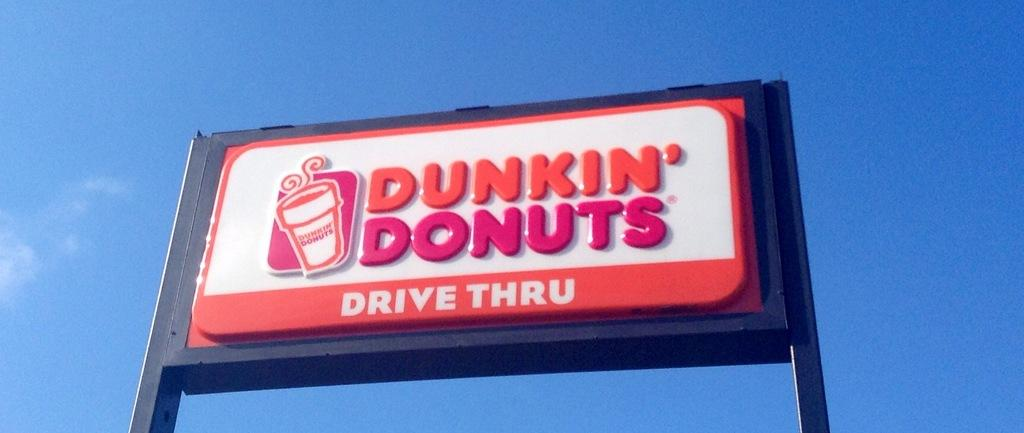<image>
Present a compact description of the photo's key features. An orange and white Dunkin Donuts signboard has a cup of coffee on it. 